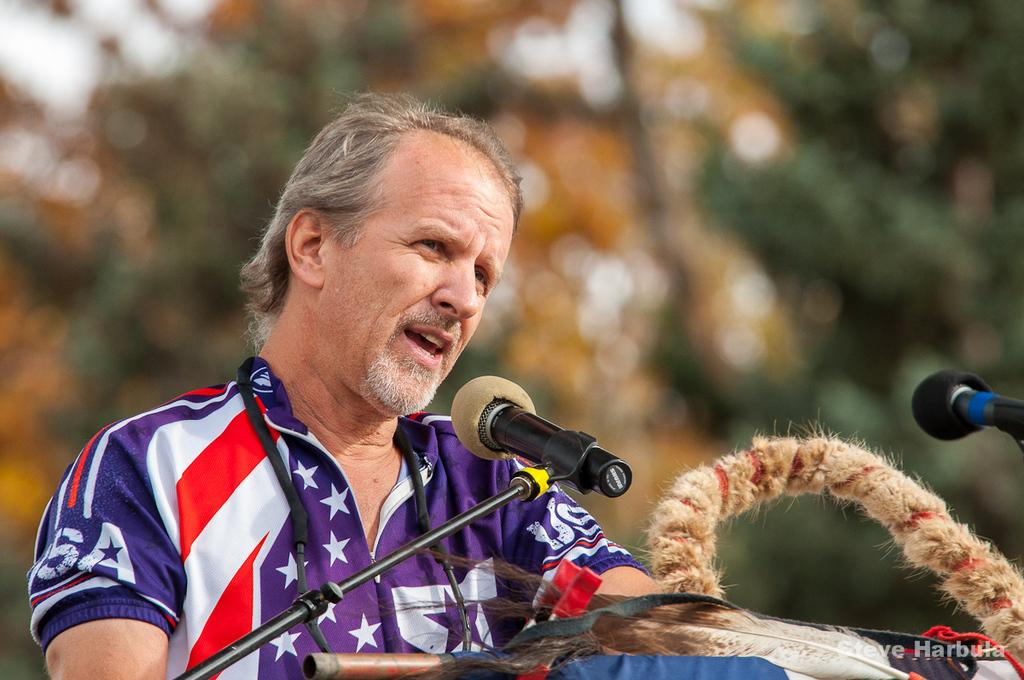What is happening in the image? There is a person in the image who is talking. What is in front of the person? There are two microphones in front of the person. What else can be seen on the table? There are other objects on the table. Can you describe the background of the image? The background of the image is blurred. What type of frog can be seen sitting on the coal in the image? There is no frog or coal present in the image. How many bulbs are visible in the image? There are no bulbs visible in the image. 